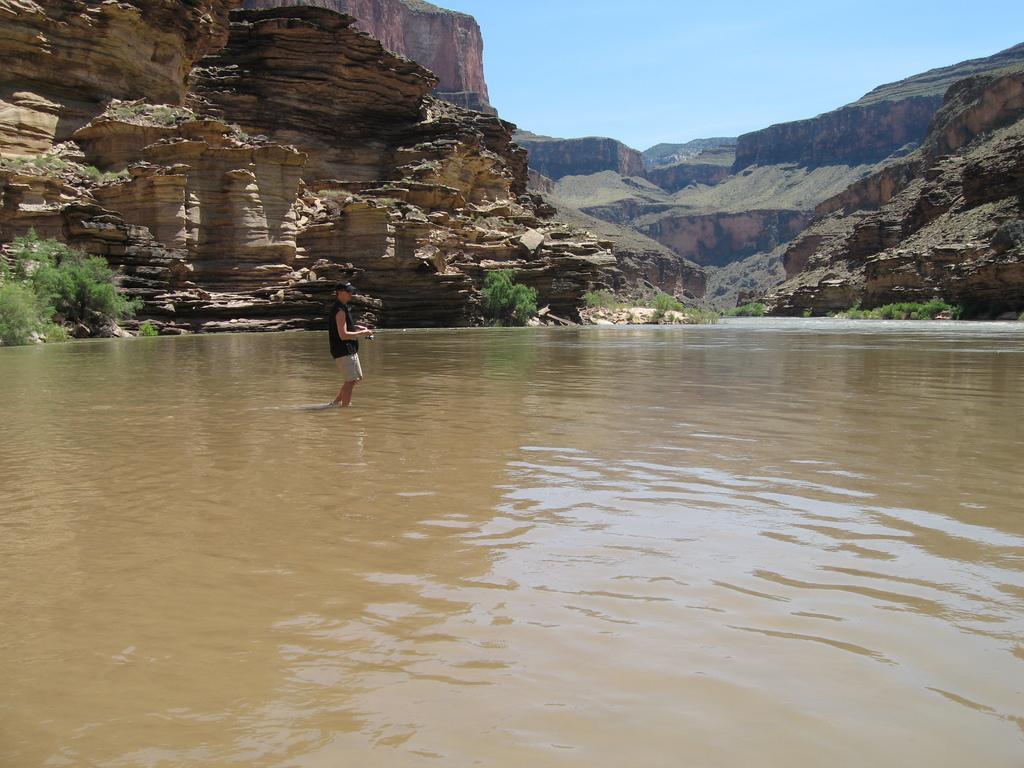Describe this image in one or two sentences. This image is clicked outside. There are bushes on the left side. There is water in the middle. There is a person standing in the middle. There is sky at the top. 